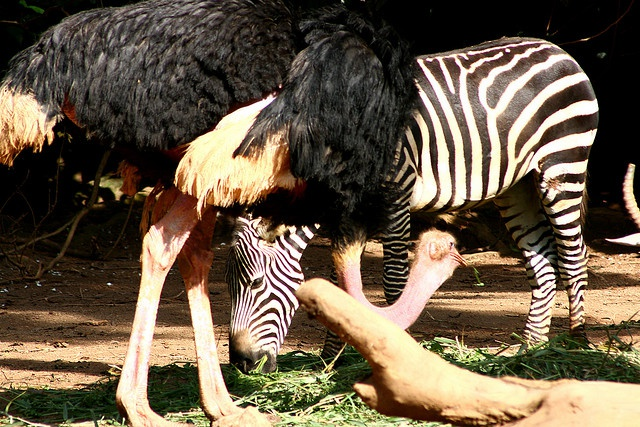Describe the objects in this image and their specific colors. I can see bird in black, beige, gray, and maroon tones and zebra in black, ivory, maroon, and gray tones in this image. 